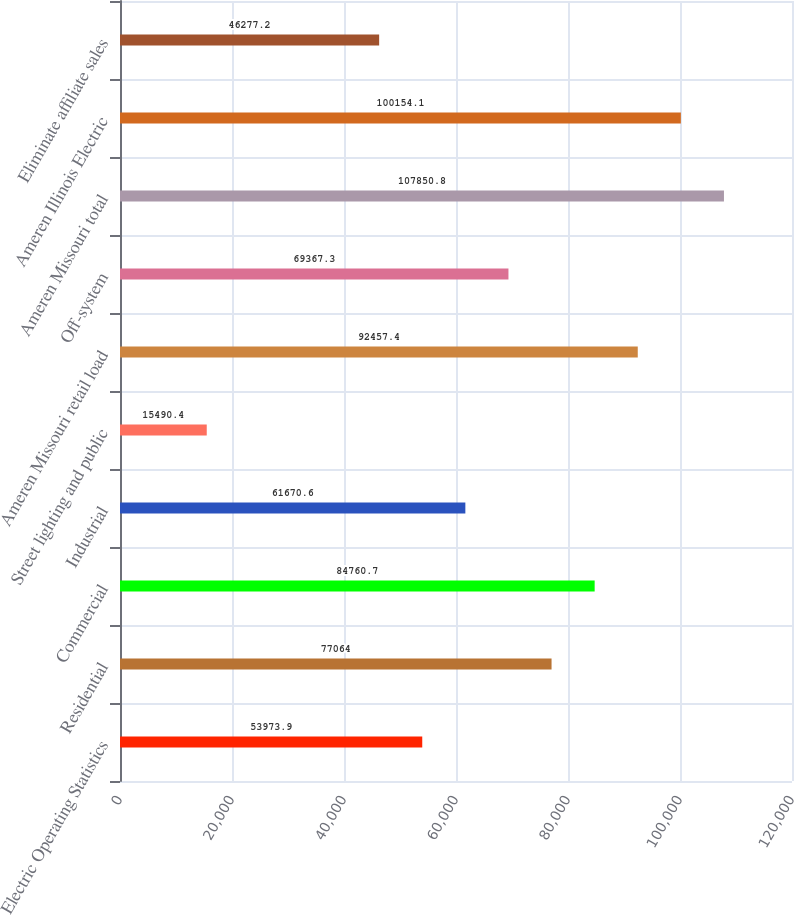<chart> <loc_0><loc_0><loc_500><loc_500><bar_chart><fcel>Electric Operating Statistics<fcel>Residential<fcel>Commercial<fcel>Industrial<fcel>Street lighting and public<fcel>Ameren Missouri retail load<fcel>Off-system<fcel>Ameren Missouri total<fcel>Ameren Illinois Electric<fcel>Eliminate affiliate sales<nl><fcel>53973.9<fcel>77064<fcel>84760.7<fcel>61670.6<fcel>15490.4<fcel>92457.4<fcel>69367.3<fcel>107851<fcel>100154<fcel>46277.2<nl></chart> 